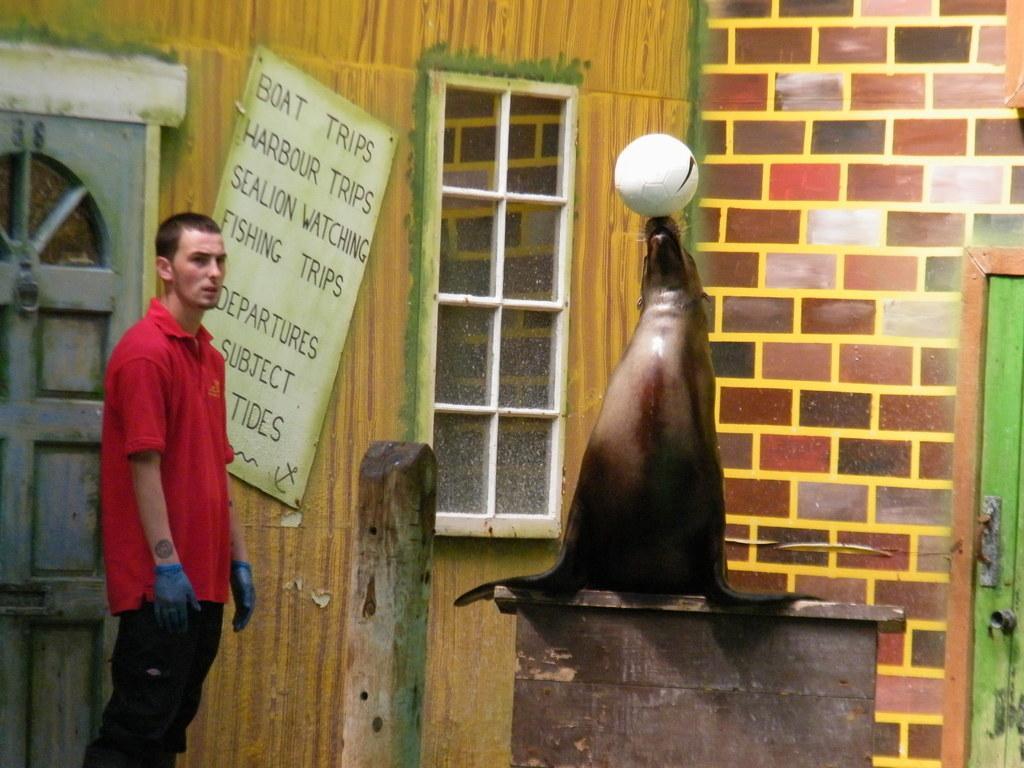Could you give a brief overview of what you see in this image? In this image we can see a person standing. We can also see a statue placed on the table and a wooden pole. On the backside we can see a building with windows, doors and a board with some text on it which is pinned to a wall. 